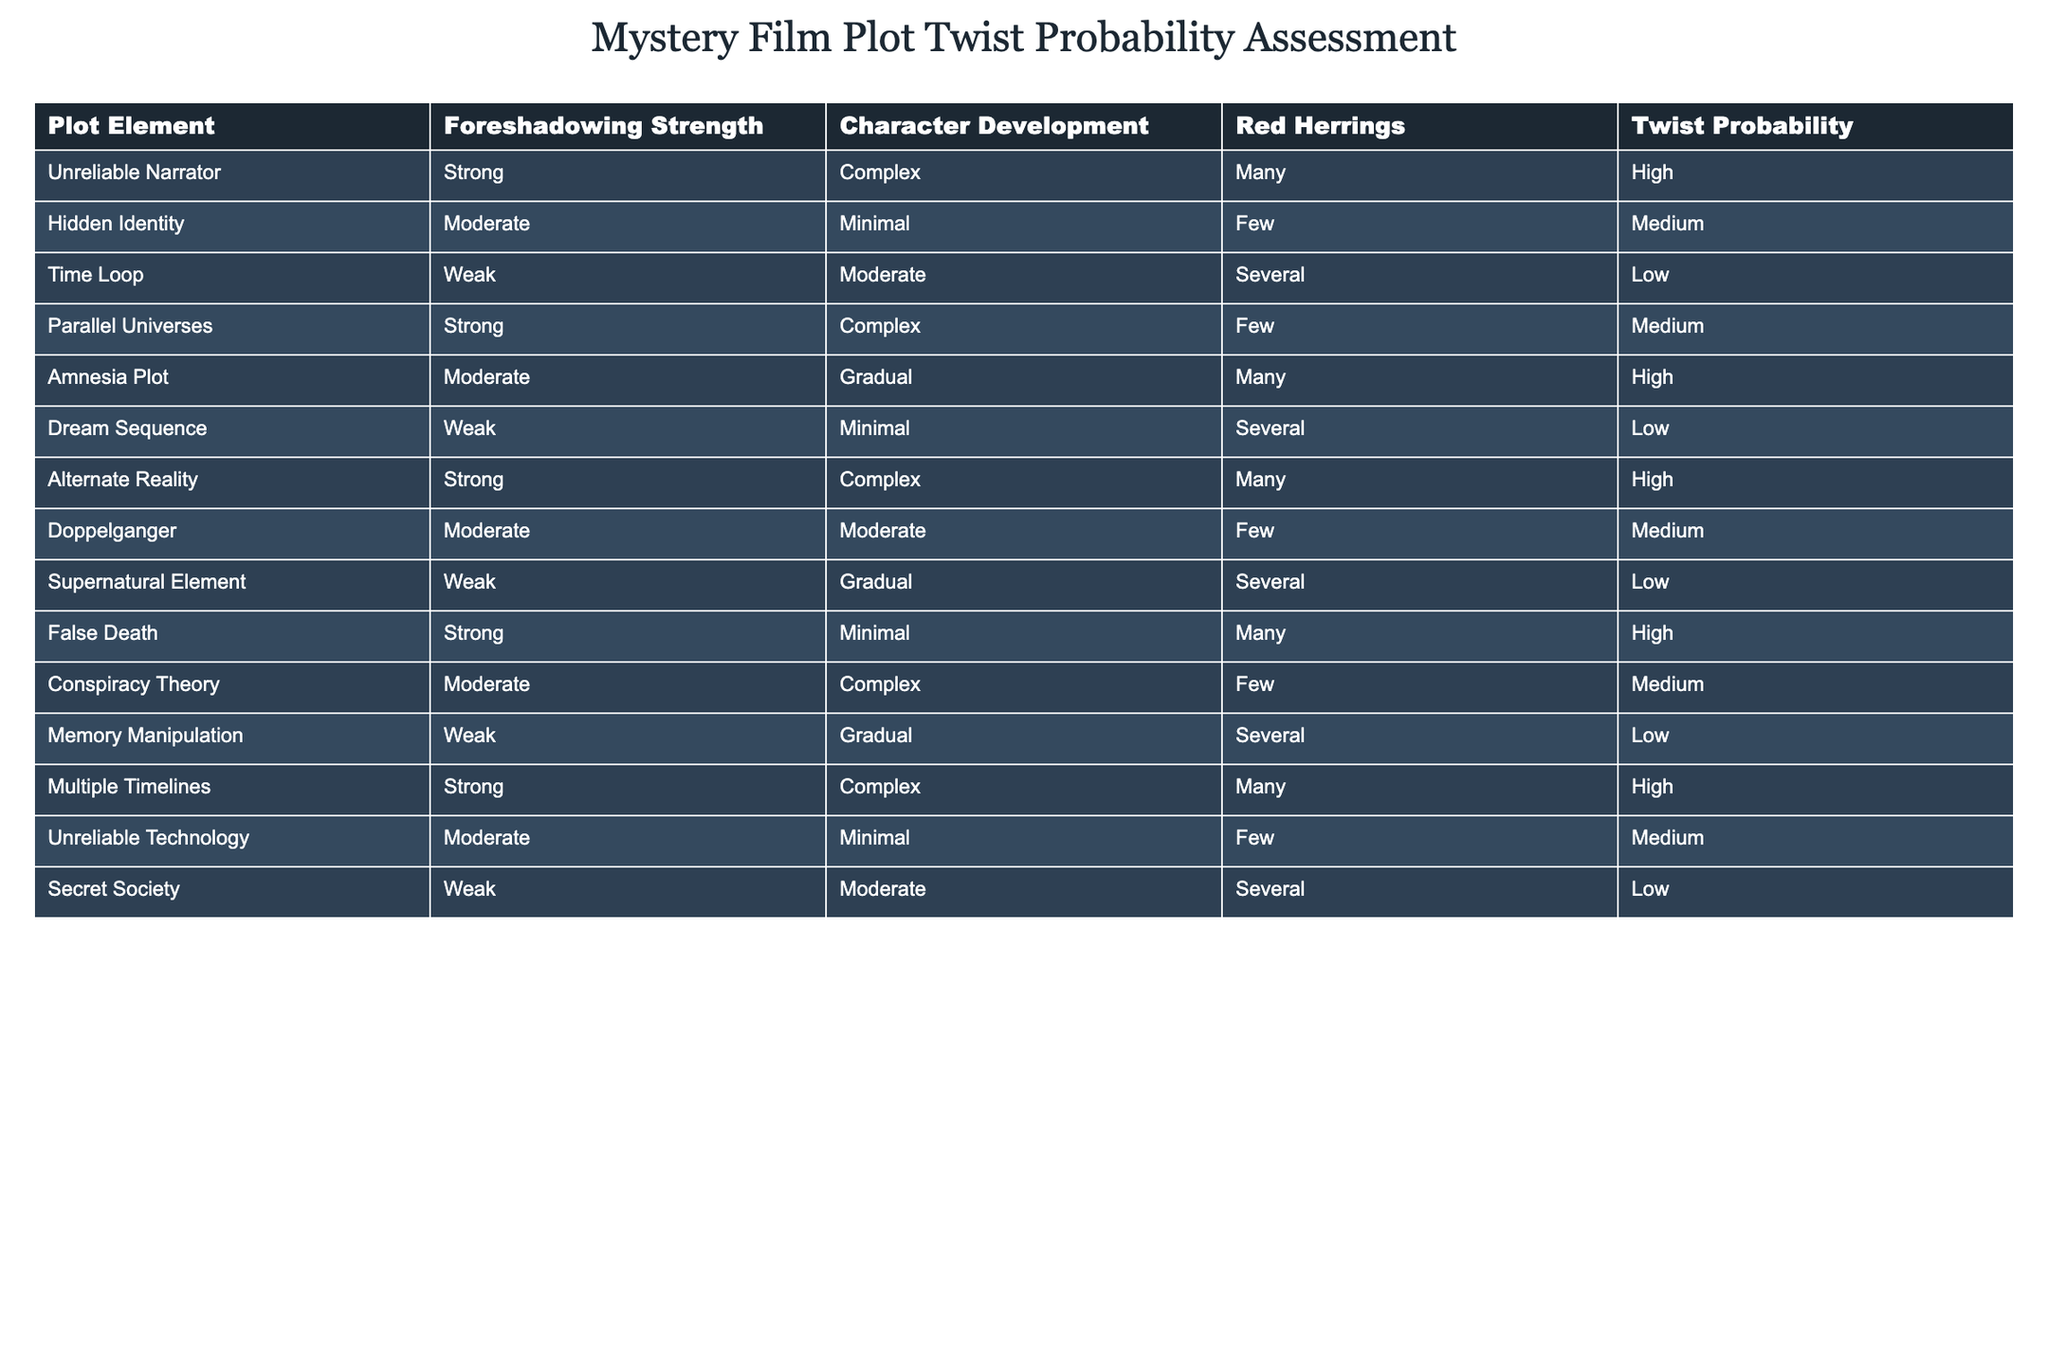What is the twist probability for an unreliable narrator? The table indicates a high twist probability for the plot element "Unreliable Narrator." This can be directly retrieved from the corresponding row under the column "Twist Probability."
Answer: High Which plot elements have a strong foreshadowing strength? By assessing the "Foreshadowing Strength" column, the plot elements listed with a strong strength are "Unreliable Narrator," "Parallel Universes," "Alternate Reality," "False Death," and "Multiple Timelines."
Answer: Unreliable Narrator, Parallel Universes, Alternate Reality, False Death, Multiple Timelines Is the twist probability for a hidden identity higher than that for a time loop? The twist probability for "Hidden Identity" is medium, while for "Time Loop" it is low. Since medium is considered higher than low, the statement is true.
Answer: Yes What is the average twist probability of all plot elements with a complex character development? The plot elements with complex character development are "Unreliable Narrator," "Parallel Universes," "Alternate Reality," "Conspiracy Theory," "Multiple Timelines." Their twist probabilities are high, medium, high, medium, and high. To calculate the average: High (counted as 1), Medium (counted as 0.5) results in (1 + 0.5 + 1 + 0.5 + 1) / 5 = 4 / 5 = 0.8 or 80%.
Answer: 80% Does the presence of red herrings influence the twist probability of an amnesia plot? The twist probability for "Amnesia Plot" is high, while the number of red herrings is many. This suggests that while many red herrings are present, they do not impede, but rather contribute positively to the high twist probability. Therefore, it can be inferred that the presence of red herrings does not negatively impact the twist probability for this plot type.
Answer: Yes 